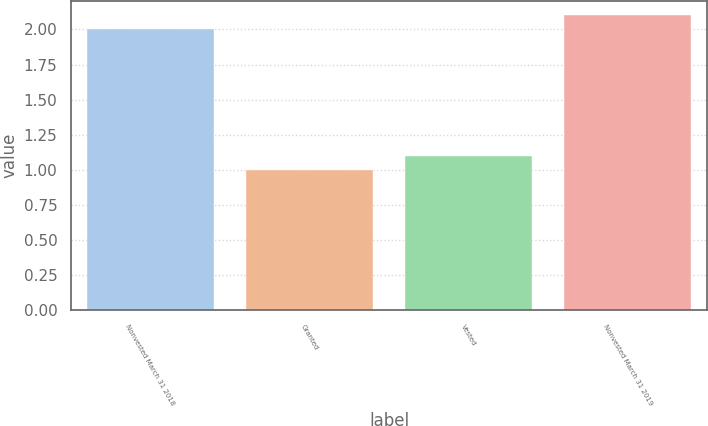Convert chart. <chart><loc_0><loc_0><loc_500><loc_500><bar_chart><fcel>Nonvested March 31 2018<fcel>Granted<fcel>Vested<fcel>Nonvested March 31 2019<nl><fcel>2<fcel>1<fcel>1.1<fcel>2.1<nl></chart> 